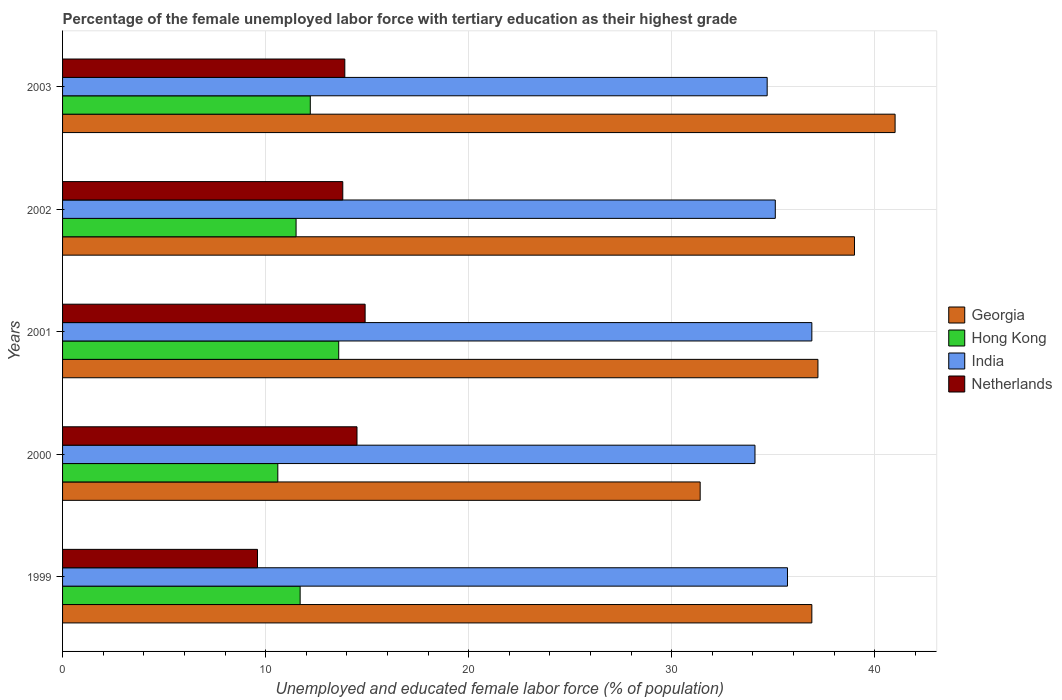Are the number of bars on each tick of the Y-axis equal?
Offer a very short reply. Yes. How many bars are there on the 3rd tick from the top?
Your response must be concise. 4. In how many cases, is the number of bars for a given year not equal to the number of legend labels?
Keep it short and to the point. 0. What is the percentage of the unemployed female labor force with tertiary education in Hong Kong in 2000?
Offer a very short reply. 10.6. Across all years, what is the minimum percentage of the unemployed female labor force with tertiary education in Hong Kong?
Make the answer very short. 10.6. What is the total percentage of the unemployed female labor force with tertiary education in India in the graph?
Keep it short and to the point. 176.5. What is the difference between the percentage of the unemployed female labor force with tertiary education in India in 2000 and that in 2001?
Make the answer very short. -2.8. What is the difference between the percentage of the unemployed female labor force with tertiary education in Netherlands in 1999 and the percentage of the unemployed female labor force with tertiary education in Hong Kong in 2002?
Provide a succinct answer. -1.9. What is the average percentage of the unemployed female labor force with tertiary education in Hong Kong per year?
Your response must be concise. 11.92. In the year 2002, what is the difference between the percentage of the unemployed female labor force with tertiary education in India and percentage of the unemployed female labor force with tertiary education in Hong Kong?
Your answer should be very brief. 23.6. What is the ratio of the percentage of the unemployed female labor force with tertiary education in Netherlands in 1999 to that in 2002?
Provide a short and direct response. 0.7. Is the difference between the percentage of the unemployed female labor force with tertiary education in India in 2000 and 2002 greater than the difference between the percentage of the unemployed female labor force with tertiary education in Hong Kong in 2000 and 2002?
Your response must be concise. No. What is the difference between the highest and the second highest percentage of the unemployed female labor force with tertiary education in India?
Give a very brief answer. 1.2. What is the difference between the highest and the lowest percentage of the unemployed female labor force with tertiary education in Netherlands?
Offer a terse response. 5.3. Is the sum of the percentage of the unemployed female labor force with tertiary education in Hong Kong in 1999 and 2001 greater than the maximum percentage of the unemployed female labor force with tertiary education in India across all years?
Ensure brevity in your answer.  No. Is it the case that in every year, the sum of the percentage of the unemployed female labor force with tertiary education in Hong Kong and percentage of the unemployed female labor force with tertiary education in Netherlands is greater than the sum of percentage of the unemployed female labor force with tertiary education in Georgia and percentage of the unemployed female labor force with tertiary education in India?
Provide a succinct answer. No. How many bars are there?
Your answer should be compact. 20. What is the difference between two consecutive major ticks on the X-axis?
Offer a very short reply. 10. Does the graph contain grids?
Provide a succinct answer. Yes. Where does the legend appear in the graph?
Offer a terse response. Center right. How many legend labels are there?
Offer a terse response. 4. How are the legend labels stacked?
Offer a terse response. Vertical. What is the title of the graph?
Offer a very short reply. Percentage of the female unemployed labor force with tertiary education as their highest grade. Does "Botswana" appear as one of the legend labels in the graph?
Keep it short and to the point. No. What is the label or title of the X-axis?
Give a very brief answer. Unemployed and educated female labor force (% of population). What is the label or title of the Y-axis?
Keep it short and to the point. Years. What is the Unemployed and educated female labor force (% of population) in Georgia in 1999?
Provide a succinct answer. 36.9. What is the Unemployed and educated female labor force (% of population) of Hong Kong in 1999?
Keep it short and to the point. 11.7. What is the Unemployed and educated female labor force (% of population) of India in 1999?
Provide a succinct answer. 35.7. What is the Unemployed and educated female labor force (% of population) in Netherlands in 1999?
Keep it short and to the point. 9.6. What is the Unemployed and educated female labor force (% of population) of Georgia in 2000?
Your response must be concise. 31.4. What is the Unemployed and educated female labor force (% of population) of Hong Kong in 2000?
Your answer should be compact. 10.6. What is the Unemployed and educated female labor force (% of population) in India in 2000?
Provide a short and direct response. 34.1. What is the Unemployed and educated female labor force (% of population) in Georgia in 2001?
Ensure brevity in your answer.  37.2. What is the Unemployed and educated female labor force (% of population) in Hong Kong in 2001?
Ensure brevity in your answer.  13.6. What is the Unemployed and educated female labor force (% of population) of India in 2001?
Give a very brief answer. 36.9. What is the Unemployed and educated female labor force (% of population) in Netherlands in 2001?
Provide a short and direct response. 14.9. What is the Unemployed and educated female labor force (% of population) of India in 2002?
Provide a short and direct response. 35.1. What is the Unemployed and educated female labor force (% of population) in Netherlands in 2002?
Ensure brevity in your answer.  13.8. What is the Unemployed and educated female labor force (% of population) of Hong Kong in 2003?
Provide a succinct answer. 12.2. What is the Unemployed and educated female labor force (% of population) in India in 2003?
Your response must be concise. 34.7. What is the Unemployed and educated female labor force (% of population) in Netherlands in 2003?
Provide a short and direct response. 13.9. Across all years, what is the maximum Unemployed and educated female labor force (% of population) of Georgia?
Offer a terse response. 41. Across all years, what is the maximum Unemployed and educated female labor force (% of population) in Hong Kong?
Offer a terse response. 13.6. Across all years, what is the maximum Unemployed and educated female labor force (% of population) in India?
Offer a very short reply. 36.9. Across all years, what is the maximum Unemployed and educated female labor force (% of population) in Netherlands?
Keep it short and to the point. 14.9. Across all years, what is the minimum Unemployed and educated female labor force (% of population) in Georgia?
Keep it short and to the point. 31.4. Across all years, what is the minimum Unemployed and educated female labor force (% of population) of Hong Kong?
Your answer should be very brief. 10.6. Across all years, what is the minimum Unemployed and educated female labor force (% of population) in India?
Provide a succinct answer. 34.1. Across all years, what is the minimum Unemployed and educated female labor force (% of population) in Netherlands?
Keep it short and to the point. 9.6. What is the total Unemployed and educated female labor force (% of population) of Georgia in the graph?
Provide a succinct answer. 185.5. What is the total Unemployed and educated female labor force (% of population) in Hong Kong in the graph?
Your answer should be very brief. 59.6. What is the total Unemployed and educated female labor force (% of population) in India in the graph?
Keep it short and to the point. 176.5. What is the total Unemployed and educated female labor force (% of population) in Netherlands in the graph?
Make the answer very short. 66.7. What is the difference between the Unemployed and educated female labor force (% of population) of Netherlands in 1999 and that in 2000?
Ensure brevity in your answer.  -4.9. What is the difference between the Unemployed and educated female labor force (% of population) of Georgia in 1999 and that in 2001?
Offer a very short reply. -0.3. What is the difference between the Unemployed and educated female labor force (% of population) of India in 1999 and that in 2001?
Keep it short and to the point. -1.2. What is the difference between the Unemployed and educated female labor force (% of population) of Netherlands in 1999 and that in 2001?
Provide a succinct answer. -5.3. What is the difference between the Unemployed and educated female labor force (% of population) of Georgia in 1999 and that in 2002?
Provide a succinct answer. -2.1. What is the difference between the Unemployed and educated female labor force (% of population) in Hong Kong in 1999 and that in 2002?
Keep it short and to the point. 0.2. What is the difference between the Unemployed and educated female labor force (% of population) of Hong Kong in 1999 and that in 2003?
Offer a very short reply. -0.5. What is the difference between the Unemployed and educated female labor force (% of population) of Netherlands in 2000 and that in 2001?
Your answer should be compact. -0.4. What is the difference between the Unemployed and educated female labor force (% of population) in Georgia in 2000 and that in 2002?
Your response must be concise. -7.6. What is the difference between the Unemployed and educated female labor force (% of population) in Hong Kong in 2000 and that in 2003?
Your response must be concise. -1.6. What is the difference between the Unemployed and educated female labor force (% of population) in India in 2000 and that in 2003?
Your answer should be compact. -0.6. What is the difference between the Unemployed and educated female labor force (% of population) in Netherlands in 2000 and that in 2003?
Provide a succinct answer. 0.6. What is the difference between the Unemployed and educated female labor force (% of population) in Hong Kong in 2001 and that in 2002?
Your answer should be very brief. 2.1. What is the difference between the Unemployed and educated female labor force (% of population) in India in 2001 and that in 2002?
Keep it short and to the point. 1.8. What is the difference between the Unemployed and educated female labor force (% of population) in Netherlands in 2001 and that in 2002?
Give a very brief answer. 1.1. What is the difference between the Unemployed and educated female labor force (% of population) in India in 2001 and that in 2003?
Keep it short and to the point. 2.2. What is the difference between the Unemployed and educated female labor force (% of population) of Georgia in 2002 and that in 2003?
Offer a very short reply. -2. What is the difference between the Unemployed and educated female labor force (% of population) of Georgia in 1999 and the Unemployed and educated female labor force (% of population) of Hong Kong in 2000?
Your answer should be very brief. 26.3. What is the difference between the Unemployed and educated female labor force (% of population) in Georgia in 1999 and the Unemployed and educated female labor force (% of population) in India in 2000?
Keep it short and to the point. 2.8. What is the difference between the Unemployed and educated female labor force (% of population) in Georgia in 1999 and the Unemployed and educated female labor force (% of population) in Netherlands in 2000?
Give a very brief answer. 22.4. What is the difference between the Unemployed and educated female labor force (% of population) in Hong Kong in 1999 and the Unemployed and educated female labor force (% of population) in India in 2000?
Offer a very short reply. -22.4. What is the difference between the Unemployed and educated female labor force (% of population) of India in 1999 and the Unemployed and educated female labor force (% of population) of Netherlands in 2000?
Give a very brief answer. 21.2. What is the difference between the Unemployed and educated female labor force (% of population) in Georgia in 1999 and the Unemployed and educated female labor force (% of population) in Hong Kong in 2001?
Give a very brief answer. 23.3. What is the difference between the Unemployed and educated female labor force (% of population) in Hong Kong in 1999 and the Unemployed and educated female labor force (% of population) in India in 2001?
Make the answer very short. -25.2. What is the difference between the Unemployed and educated female labor force (% of population) of India in 1999 and the Unemployed and educated female labor force (% of population) of Netherlands in 2001?
Make the answer very short. 20.8. What is the difference between the Unemployed and educated female labor force (% of population) in Georgia in 1999 and the Unemployed and educated female labor force (% of population) in Hong Kong in 2002?
Your answer should be compact. 25.4. What is the difference between the Unemployed and educated female labor force (% of population) of Georgia in 1999 and the Unemployed and educated female labor force (% of population) of India in 2002?
Provide a short and direct response. 1.8. What is the difference between the Unemployed and educated female labor force (% of population) in Georgia in 1999 and the Unemployed and educated female labor force (% of population) in Netherlands in 2002?
Provide a succinct answer. 23.1. What is the difference between the Unemployed and educated female labor force (% of population) of Hong Kong in 1999 and the Unemployed and educated female labor force (% of population) of India in 2002?
Keep it short and to the point. -23.4. What is the difference between the Unemployed and educated female labor force (% of population) in Hong Kong in 1999 and the Unemployed and educated female labor force (% of population) in Netherlands in 2002?
Provide a short and direct response. -2.1. What is the difference between the Unemployed and educated female labor force (% of population) in India in 1999 and the Unemployed and educated female labor force (% of population) in Netherlands in 2002?
Give a very brief answer. 21.9. What is the difference between the Unemployed and educated female labor force (% of population) in Georgia in 1999 and the Unemployed and educated female labor force (% of population) in Hong Kong in 2003?
Ensure brevity in your answer.  24.7. What is the difference between the Unemployed and educated female labor force (% of population) in Georgia in 1999 and the Unemployed and educated female labor force (% of population) in India in 2003?
Your answer should be compact. 2.2. What is the difference between the Unemployed and educated female labor force (% of population) in Georgia in 1999 and the Unemployed and educated female labor force (% of population) in Netherlands in 2003?
Keep it short and to the point. 23. What is the difference between the Unemployed and educated female labor force (% of population) of Hong Kong in 1999 and the Unemployed and educated female labor force (% of population) of India in 2003?
Keep it short and to the point. -23. What is the difference between the Unemployed and educated female labor force (% of population) in India in 1999 and the Unemployed and educated female labor force (% of population) in Netherlands in 2003?
Your answer should be compact. 21.8. What is the difference between the Unemployed and educated female labor force (% of population) in Hong Kong in 2000 and the Unemployed and educated female labor force (% of population) in India in 2001?
Keep it short and to the point. -26.3. What is the difference between the Unemployed and educated female labor force (% of population) in Georgia in 2000 and the Unemployed and educated female labor force (% of population) in Hong Kong in 2002?
Keep it short and to the point. 19.9. What is the difference between the Unemployed and educated female labor force (% of population) of Georgia in 2000 and the Unemployed and educated female labor force (% of population) of Netherlands in 2002?
Your answer should be compact. 17.6. What is the difference between the Unemployed and educated female labor force (% of population) in Hong Kong in 2000 and the Unemployed and educated female labor force (% of population) in India in 2002?
Provide a short and direct response. -24.5. What is the difference between the Unemployed and educated female labor force (% of population) in Hong Kong in 2000 and the Unemployed and educated female labor force (% of population) in Netherlands in 2002?
Provide a succinct answer. -3.2. What is the difference between the Unemployed and educated female labor force (% of population) of India in 2000 and the Unemployed and educated female labor force (% of population) of Netherlands in 2002?
Provide a short and direct response. 20.3. What is the difference between the Unemployed and educated female labor force (% of population) in Georgia in 2000 and the Unemployed and educated female labor force (% of population) in Hong Kong in 2003?
Give a very brief answer. 19.2. What is the difference between the Unemployed and educated female labor force (% of population) of Georgia in 2000 and the Unemployed and educated female labor force (% of population) of India in 2003?
Offer a terse response. -3.3. What is the difference between the Unemployed and educated female labor force (% of population) in Hong Kong in 2000 and the Unemployed and educated female labor force (% of population) in India in 2003?
Provide a short and direct response. -24.1. What is the difference between the Unemployed and educated female labor force (% of population) in Hong Kong in 2000 and the Unemployed and educated female labor force (% of population) in Netherlands in 2003?
Your answer should be compact. -3.3. What is the difference between the Unemployed and educated female labor force (% of population) of India in 2000 and the Unemployed and educated female labor force (% of population) of Netherlands in 2003?
Your answer should be very brief. 20.2. What is the difference between the Unemployed and educated female labor force (% of population) of Georgia in 2001 and the Unemployed and educated female labor force (% of population) of Hong Kong in 2002?
Your answer should be very brief. 25.7. What is the difference between the Unemployed and educated female labor force (% of population) of Georgia in 2001 and the Unemployed and educated female labor force (% of population) of India in 2002?
Your response must be concise. 2.1. What is the difference between the Unemployed and educated female labor force (% of population) in Georgia in 2001 and the Unemployed and educated female labor force (% of population) in Netherlands in 2002?
Provide a short and direct response. 23.4. What is the difference between the Unemployed and educated female labor force (% of population) in Hong Kong in 2001 and the Unemployed and educated female labor force (% of population) in India in 2002?
Your answer should be compact. -21.5. What is the difference between the Unemployed and educated female labor force (% of population) of Hong Kong in 2001 and the Unemployed and educated female labor force (% of population) of Netherlands in 2002?
Make the answer very short. -0.2. What is the difference between the Unemployed and educated female labor force (% of population) of India in 2001 and the Unemployed and educated female labor force (% of population) of Netherlands in 2002?
Offer a terse response. 23.1. What is the difference between the Unemployed and educated female labor force (% of population) of Georgia in 2001 and the Unemployed and educated female labor force (% of population) of Hong Kong in 2003?
Ensure brevity in your answer.  25. What is the difference between the Unemployed and educated female labor force (% of population) in Georgia in 2001 and the Unemployed and educated female labor force (% of population) in India in 2003?
Ensure brevity in your answer.  2.5. What is the difference between the Unemployed and educated female labor force (% of population) of Georgia in 2001 and the Unemployed and educated female labor force (% of population) of Netherlands in 2003?
Keep it short and to the point. 23.3. What is the difference between the Unemployed and educated female labor force (% of population) in Hong Kong in 2001 and the Unemployed and educated female labor force (% of population) in India in 2003?
Your response must be concise. -21.1. What is the difference between the Unemployed and educated female labor force (% of population) of India in 2001 and the Unemployed and educated female labor force (% of population) of Netherlands in 2003?
Provide a short and direct response. 23. What is the difference between the Unemployed and educated female labor force (% of population) in Georgia in 2002 and the Unemployed and educated female labor force (% of population) in Hong Kong in 2003?
Your response must be concise. 26.8. What is the difference between the Unemployed and educated female labor force (% of population) in Georgia in 2002 and the Unemployed and educated female labor force (% of population) in India in 2003?
Give a very brief answer. 4.3. What is the difference between the Unemployed and educated female labor force (% of population) in Georgia in 2002 and the Unemployed and educated female labor force (% of population) in Netherlands in 2003?
Provide a short and direct response. 25.1. What is the difference between the Unemployed and educated female labor force (% of population) of Hong Kong in 2002 and the Unemployed and educated female labor force (% of population) of India in 2003?
Offer a very short reply. -23.2. What is the difference between the Unemployed and educated female labor force (% of population) in Hong Kong in 2002 and the Unemployed and educated female labor force (% of population) in Netherlands in 2003?
Offer a very short reply. -2.4. What is the difference between the Unemployed and educated female labor force (% of population) in India in 2002 and the Unemployed and educated female labor force (% of population) in Netherlands in 2003?
Your answer should be compact. 21.2. What is the average Unemployed and educated female labor force (% of population) in Georgia per year?
Your answer should be very brief. 37.1. What is the average Unemployed and educated female labor force (% of population) in Hong Kong per year?
Keep it short and to the point. 11.92. What is the average Unemployed and educated female labor force (% of population) of India per year?
Offer a very short reply. 35.3. What is the average Unemployed and educated female labor force (% of population) of Netherlands per year?
Offer a terse response. 13.34. In the year 1999, what is the difference between the Unemployed and educated female labor force (% of population) of Georgia and Unemployed and educated female labor force (% of population) of Hong Kong?
Make the answer very short. 25.2. In the year 1999, what is the difference between the Unemployed and educated female labor force (% of population) in Georgia and Unemployed and educated female labor force (% of population) in India?
Give a very brief answer. 1.2. In the year 1999, what is the difference between the Unemployed and educated female labor force (% of population) in Georgia and Unemployed and educated female labor force (% of population) in Netherlands?
Your answer should be very brief. 27.3. In the year 1999, what is the difference between the Unemployed and educated female labor force (% of population) of India and Unemployed and educated female labor force (% of population) of Netherlands?
Offer a terse response. 26.1. In the year 2000, what is the difference between the Unemployed and educated female labor force (% of population) in Georgia and Unemployed and educated female labor force (% of population) in Hong Kong?
Keep it short and to the point. 20.8. In the year 2000, what is the difference between the Unemployed and educated female labor force (% of population) of Georgia and Unemployed and educated female labor force (% of population) of India?
Provide a short and direct response. -2.7. In the year 2000, what is the difference between the Unemployed and educated female labor force (% of population) in Georgia and Unemployed and educated female labor force (% of population) in Netherlands?
Give a very brief answer. 16.9. In the year 2000, what is the difference between the Unemployed and educated female labor force (% of population) in Hong Kong and Unemployed and educated female labor force (% of population) in India?
Your answer should be very brief. -23.5. In the year 2000, what is the difference between the Unemployed and educated female labor force (% of population) in India and Unemployed and educated female labor force (% of population) in Netherlands?
Provide a succinct answer. 19.6. In the year 2001, what is the difference between the Unemployed and educated female labor force (% of population) in Georgia and Unemployed and educated female labor force (% of population) in Hong Kong?
Your response must be concise. 23.6. In the year 2001, what is the difference between the Unemployed and educated female labor force (% of population) in Georgia and Unemployed and educated female labor force (% of population) in Netherlands?
Provide a short and direct response. 22.3. In the year 2001, what is the difference between the Unemployed and educated female labor force (% of population) of Hong Kong and Unemployed and educated female labor force (% of population) of India?
Your answer should be compact. -23.3. In the year 2002, what is the difference between the Unemployed and educated female labor force (% of population) in Georgia and Unemployed and educated female labor force (% of population) in Hong Kong?
Make the answer very short. 27.5. In the year 2002, what is the difference between the Unemployed and educated female labor force (% of population) in Georgia and Unemployed and educated female labor force (% of population) in Netherlands?
Provide a succinct answer. 25.2. In the year 2002, what is the difference between the Unemployed and educated female labor force (% of population) in Hong Kong and Unemployed and educated female labor force (% of population) in India?
Offer a terse response. -23.6. In the year 2002, what is the difference between the Unemployed and educated female labor force (% of population) in India and Unemployed and educated female labor force (% of population) in Netherlands?
Your response must be concise. 21.3. In the year 2003, what is the difference between the Unemployed and educated female labor force (% of population) of Georgia and Unemployed and educated female labor force (% of population) of Hong Kong?
Your response must be concise. 28.8. In the year 2003, what is the difference between the Unemployed and educated female labor force (% of population) of Georgia and Unemployed and educated female labor force (% of population) of India?
Your response must be concise. 6.3. In the year 2003, what is the difference between the Unemployed and educated female labor force (% of population) of Georgia and Unemployed and educated female labor force (% of population) of Netherlands?
Provide a short and direct response. 27.1. In the year 2003, what is the difference between the Unemployed and educated female labor force (% of population) in Hong Kong and Unemployed and educated female labor force (% of population) in India?
Give a very brief answer. -22.5. In the year 2003, what is the difference between the Unemployed and educated female labor force (% of population) in Hong Kong and Unemployed and educated female labor force (% of population) in Netherlands?
Keep it short and to the point. -1.7. In the year 2003, what is the difference between the Unemployed and educated female labor force (% of population) of India and Unemployed and educated female labor force (% of population) of Netherlands?
Make the answer very short. 20.8. What is the ratio of the Unemployed and educated female labor force (% of population) in Georgia in 1999 to that in 2000?
Your response must be concise. 1.18. What is the ratio of the Unemployed and educated female labor force (% of population) of Hong Kong in 1999 to that in 2000?
Offer a very short reply. 1.1. What is the ratio of the Unemployed and educated female labor force (% of population) in India in 1999 to that in 2000?
Give a very brief answer. 1.05. What is the ratio of the Unemployed and educated female labor force (% of population) in Netherlands in 1999 to that in 2000?
Keep it short and to the point. 0.66. What is the ratio of the Unemployed and educated female labor force (% of population) of Hong Kong in 1999 to that in 2001?
Provide a succinct answer. 0.86. What is the ratio of the Unemployed and educated female labor force (% of population) in India in 1999 to that in 2001?
Provide a short and direct response. 0.97. What is the ratio of the Unemployed and educated female labor force (% of population) of Netherlands in 1999 to that in 2001?
Your response must be concise. 0.64. What is the ratio of the Unemployed and educated female labor force (% of population) of Georgia in 1999 to that in 2002?
Make the answer very short. 0.95. What is the ratio of the Unemployed and educated female labor force (% of population) of Hong Kong in 1999 to that in 2002?
Your answer should be compact. 1.02. What is the ratio of the Unemployed and educated female labor force (% of population) of India in 1999 to that in 2002?
Offer a terse response. 1.02. What is the ratio of the Unemployed and educated female labor force (% of population) in Netherlands in 1999 to that in 2002?
Ensure brevity in your answer.  0.7. What is the ratio of the Unemployed and educated female labor force (% of population) in Hong Kong in 1999 to that in 2003?
Provide a short and direct response. 0.96. What is the ratio of the Unemployed and educated female labor force (% of population) in India in 1999 to that in 2003?
Your response must be concise. 1.03. What is the ratio of the Unemployed and educated female labor force (% of population) in Netherlands in 1999 to that in 2003?
Offer a very short reply. 0.69. What is the ratio of the Unemployed and educated female labor force (% of population) in Georgia in 2000 to that in 2001?
Ensure brevity in your answer.  0.84. What is the ratio of the Unemployed and educated female labor force (% of population) in Hong Kong in 2000 to that in 2001?
Offer a terse response. 0.78. What is the ratio of the Unemployed and educated female labor force (% of population) in India in 2000 to that in 2001?
Make the answer very short. 0.92. What is the ratio of the Unemployed and educated female labor force (% of population) in Netherlands in 2000 to that in 2001?
Provide a succinct answer. 0.97. What is the ratio of the Unemployed and educated female labor force (% of population) in Georgia in 2000 to that in 2002?
Make the answer very short. 0.81. What is the ratio of the Unemployed and educated female labor force (% of population) of Hong Kong in 2000 to that in 2002?
Provide a succinct answer. 0.92. What is the ratio of the Unemployed and educated female labor force (% of population) in India in 2000 to that in 2002?
Make the answer very short. 0.97. What is the ratio of the Unemployed and educated female labor force (% of population) of Netherlands in 2000 to that in 2002?
Ensure brevity in your answer.  1.05. What is the ratio of the Unemployed and educated female labor force (% of population) in Georgia in 2000 to that in 2003?
Your answer should be very brief. 0.77. What is the ratio of the Unemployed and educated female labor force (% of population) of Hong Kong in 2000 to that in 2003?
Your response must be concise. 0.87. What is the ratio of the Unemployed and educated female labor force (% of population) in India in 2000 to that in 2003?
Offer a terse response. 0.98. What is the ratio of the Unemployed and educated female labor force (% of population) in Netherlands in 2000 to that in 2003?
Ensure brevity in your answer.  1.04. What is the ratio of the Unemployed and educated female labor force (% of population) in Georgia in 2001 to that in 2002?
Provide a succinct answer. 0.95. What is the ratio of the Unemployed and educated female labor force (% of population) of Hong Kong in 2001 to that in 2002?
Keep it short and to the point. 1.18. What is the ratio of the Unemployed and educated female labor force (% of population) of India in 2001 to that in 2002?
Keep it short and to the point. 1.05. What is the ratio of the Unemployed and educated female labor force (% of population) in Netherlands in 2001 to that in 2002?
Ensure brevity in your answer.  1.08. What is the ratio of the Unemployed and educated female labor force (% of population) of Georgia in 2001 to that in 2003?
Your answer should be very brief. 0.91. What is the ratio of the Unemployed and educated female labor force (% of population) in Hong Kong in 2001 to that in 2003?
Provide a short and direct response. 1.11. What is the ratio of the Unemployed and educated female labor force (% of population) in India in 2001 to that in 2003?
Your response must be concise. 1.06. What is the ratio of the Unemployed and educated female labor force (% of population) of Netherlands in 2001 to that in 2003?
Offer a very short reply. 1.07. What is the ratio of the Unemployed and educated female labor force (% of population) of Georgia in 2002 to that in 2003?
Ensure brevity in your answer.  0.95. What is the ratio of the Unemployed and educated female labor force (% of population) in Hong Kong in 2002 to that in 2003?
Your response must be concise. 0.94. What is the ratio of the Unemployed and educated female labor force (% of population) of India in 2002 to that in 2003?
Your response must be concise. 1.01. What is the ratio of the Unemployed and educated female labor force (% of population) in Netherlands in 2002 to that in 2003?
Ensure brevity in your answer.  0.99. What is the difference between the highest and the second highest Unemployed and educated female labor force (% of population) in Georgia?
Your answer should be compact. 2. What is the difference between the highest and the second highest Unemployed and educated female labor force (% of population) of Hong Kong?
Offer a terse response. 1.4. What is the difference between the highest and the second highest Unemployed and educated female labor force (% of population) in India?
Ensure brevity in your answer.  1.2. What is the difference between the highest and the second highest Unemployed and educated female labor force (% of population) in Netherlands?
Provide a short and direct response. 0.4. What is the difference between the highest and the lowest Unemployed and educated female labor force (% of population) in Georgia?
Provide a succinct answer. 9.6. What is the difference between the highest and the lowest Unemployed and educated female labor force (% of population) of Hong Kong?
Provide a short and direct response. 3. What is the difference between the highest and the lowest Unemployed and educated female labor force (% of population) in Netherlands?
Your answer should be very brief. 5.3. 